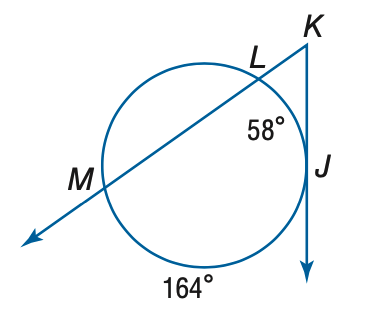Question: Find the measure of m \angle K.
Choices:
A. 26.5
B. 53
C. 58
D. 106
Answer with the letter. Answer: B 